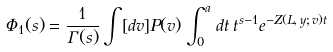<formula> <loc_0><loc_0><loc_500><loc_500>\Phi _ { 1 } ( s ) = \frac { 1 } { \Gamma ( s ) } \int [ d v ] P ( v ) \int _ { 0 } ^ { a } \, d t \, t ^ { s - 1 } e ^ { - Z ( L , \, y ; \, v ) t }</formula> 